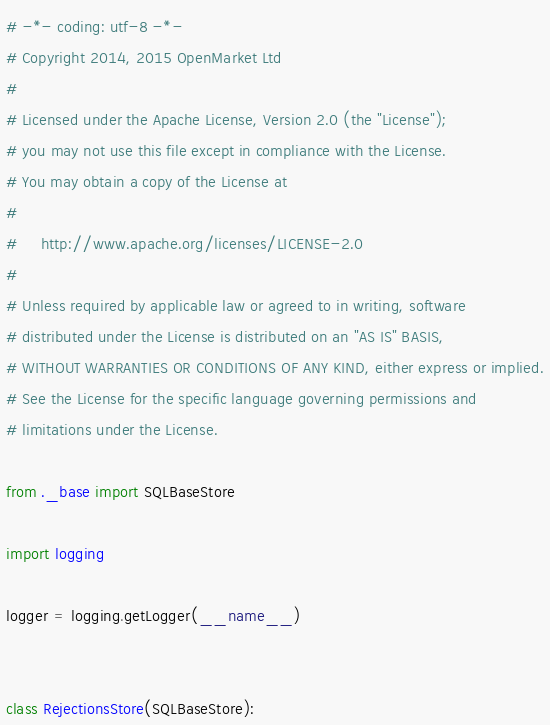<code> <loc_0><loc_0><loc_500><loc_500><_Python_># -*- coding: utf-8 -*-
# Copyright 2014, 2015 OpenMarket Ltd
#
# Licensed under the Apache License, Version 2.0 (the "License");
# you may not use this file except in compliance with the License.
# You may obtain a copy of the License at
#
#     http://www.apache.org/licenses/LICENSE-2.0
#
# Unless required by applicable law or agreed to in writing, software
# distributed under the License is distributed on an "AS IS" BASIS,
# WITHOUT WARRANTIES OR CONDITIONS OF ANY KIND, either express or implied.
# See the License for the specific language governing permissions and
# limitations under the License.

from ._base import SQLBaseStore

import logging

logger = logging.getLogger(__name__)


class RejectionsStore(SQLBaseStore):</code> 